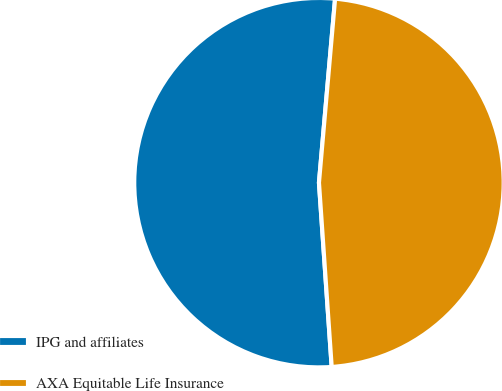Convert chart to OTSL. <chart><loc_0><loc_0><loc_500><loc_500><pie_chart><fcel>IPG and affiliates<fcel>AXA Equitable Life Insurance<nl><fcel>52.49%<fcel>47.51%<nl></chart> 